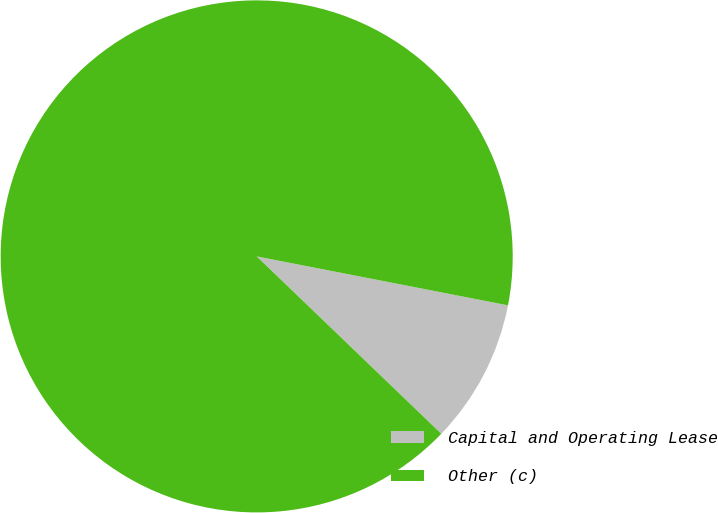Convert chart to OTSL. <chart><loc_0><loc_0><loc_500><loc_500><pie_chart><fcel>Capital and Operating Lease<fcel>Other (c)<nl><fcel>9.12%<fcel>90.88%<nl></chart> 